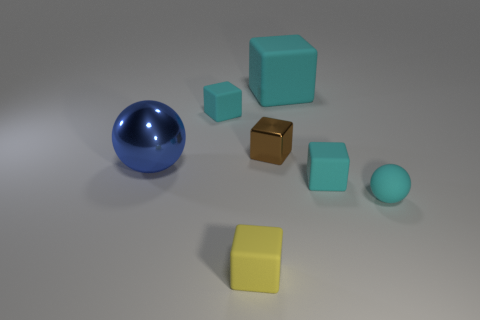Add 1 big cyan matte blocks. How many objects exist? 8 Subtract all purple balls. How many cyan cubes are left? 3 Subtract all brown cubes. How many cubes are left? 4 Subtract all tiny yellow matte cubes. How many cubes are left? 4 Subtract all purple blocks. Subtract all green cylinders. How many blocks are left? 5 Subtract all cubes. How many objects are left? 2 Subtract 0 red cylinders. How many objects are left? 7 Subtract all small brown cubes. Subtract all tiny matte balls. How many objects are left? 5 Add 7 blue objects. How many blue objects are left? 8 Add 6 tiny yellow objects. How many tiny yellow objects exist? 7 